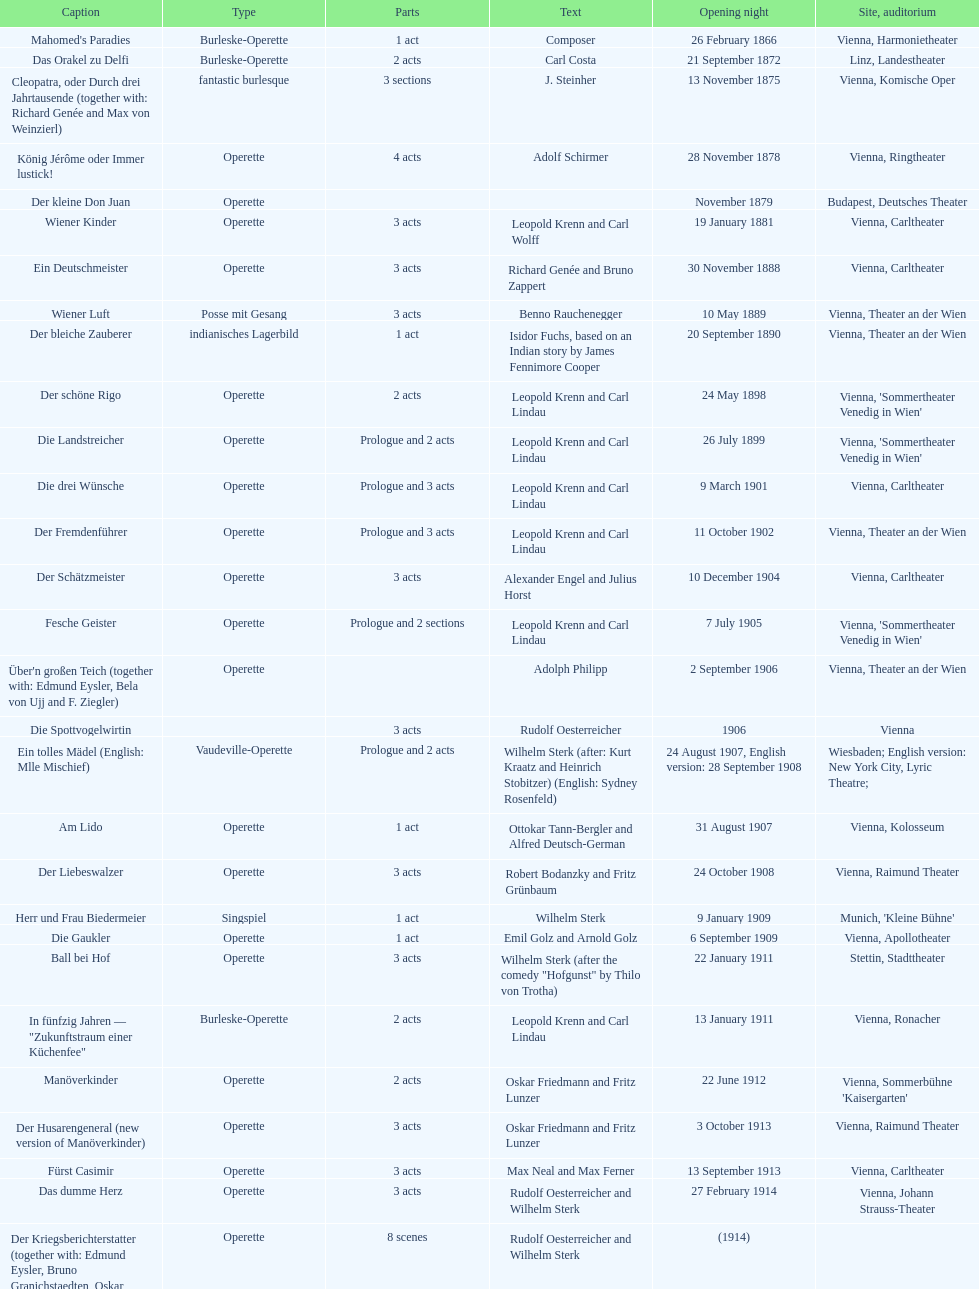How many number of 1 acts were there? 5. 